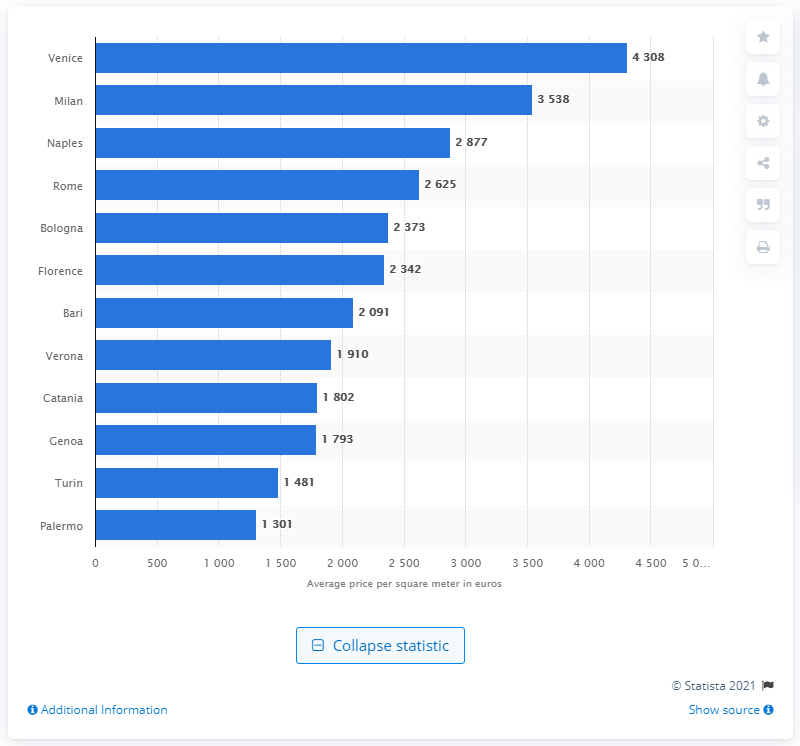Specify some key components in this picture. Milan is the fashion capital of Italy. Rome was ranked as the second city in Italy in terms of office space. In 2019, the average cost of a square meter of retail space in Venice was approximately 4,308. 